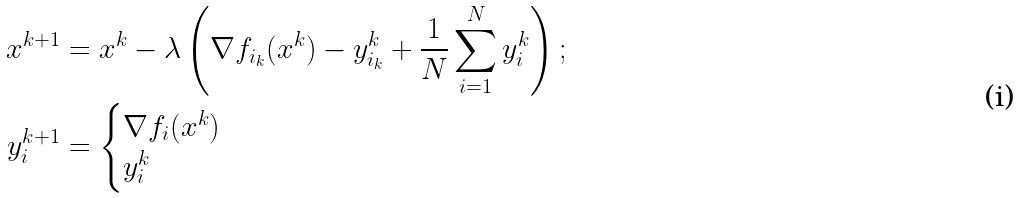Convert formula to latex. <formula><loc_0><loc_0><loc_500><loc_500>x ^ { k + 1 } & = x ^ { k } - \lambda \left ( \nabla f _ { i _ { k } } ( x ^ { k } ) - y _ { i _ { k } } ^ { k } + \frac { 1 } { N } \sum _ { i = 1 } ^ { N } y _ { i } ^ { k } \right ) ; \\ y _ { i } ^ { k + 1 } & = \begin{cases} \nabla f _ { i } ( x ^ { k } ) & \\ y _ { i } ^ { k } & \end{cases}</formula> 